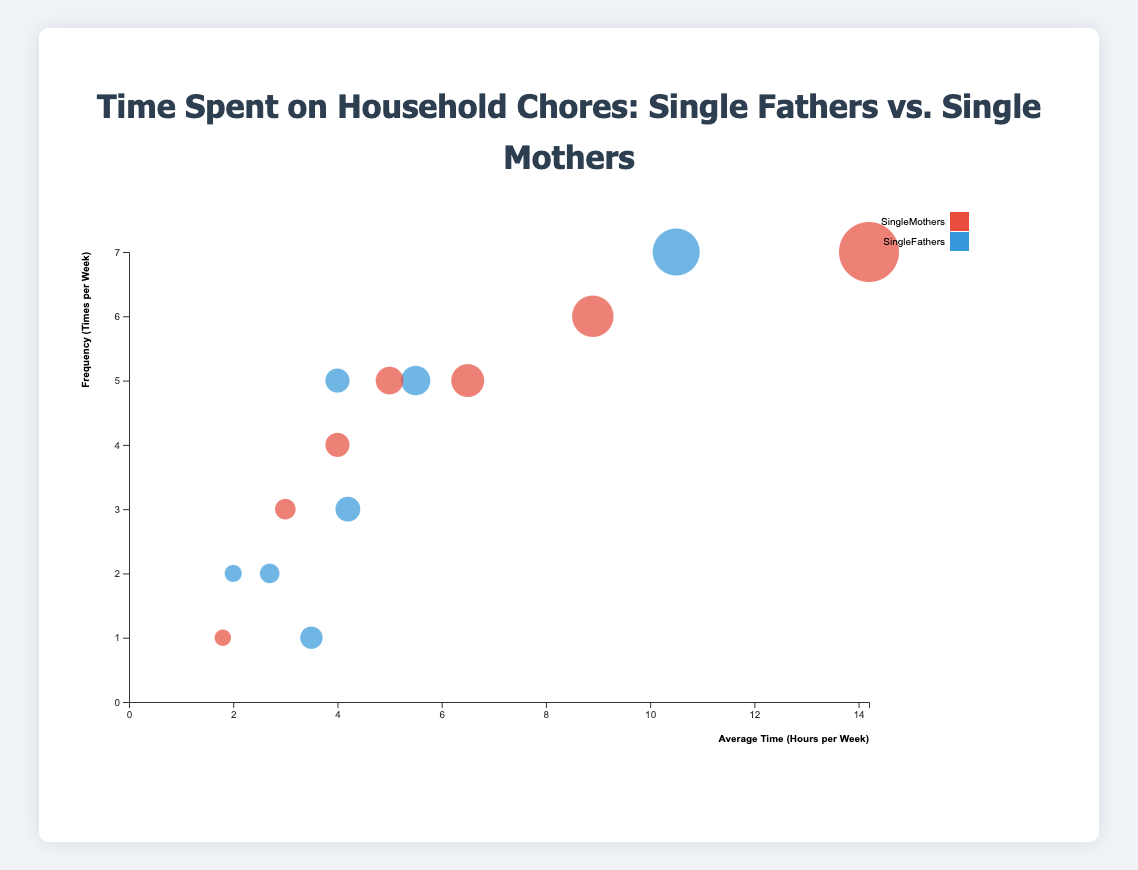What are the two chores where single fathers spend the most and least time? The chart shows bubbles representing the time spent on chores by single fathers. The largest bubble for single fathers is for 'Childcare' (10.5 hours per week) and the smallest is 'Grocery Shopping' (2.0 hours per week).
Answer: Childcare and Grocery Shopping Which chore has the smallest difference in the average time spent between single fathers and single mothers? Compare the differences in average time spent for each chore. For 'Homework Assistance,' it is 5.0 hours (mothers) - 4.0 hours (fathers) = 1.0 hour. This is the smallest difference.
Answer: Homework Assistance On average, how many more times per week do single mothers cook compared to single fathers? Check the frequencies for cooking: 6 times per week for single mothers and 5 times per week for single fathers. The difference is 6 - 5 = 1 time per week.
Answer: 1 Do single fathers or single mothers dedicate more overall time to chores on average according to this chart? Sum up the average weekly hours for each group: Single Fathers: 5.5+4.2+2.7+10.5+3.5+2.0+4.0 = 32.4 hours. Single Mothers: 8.9+6.5+4.0+14.2+1.8+3.0+5.0 = 43.4 hours. Single mothers dedicate more time.
Answer: Single mothers What is the average number of times per week that single parents (both fathers and mothers) do laundry? Add the frequencies for both fathers and mothers: 2 (fathers) + 4 (mothers) = 6. Divide by 2 to get the average: 6 / 2 = 3 times per week.
Answer: 3 Which chore has the largest bubble for single mothers, and how many hours per week is it? Identify the largest bubble for single mothers. 'Childcare' has the largest bubble. Check the corresponding average time: 14.2 hours per week.
Answer: Childcare, 14.2 hours per week Which chore appears to be done most frequently on a weekly basis by both single fathers and single mothers? The y-axis represents the frequency. The highest point for both is 'Childcare', where both have a frequency of 7 times per week.
Answer: Childcare How many chores have a frequency of at least 5 times per week for single mothers? Count the chores with a frequency of 5 or more: Cooking (6), Cleaning (5), Childcare (7), Homework Assistance (5). There are 4 such chores.
Answer: 4 Which household chore shows the biggest disparity in the average time spent per week between single fathers and single mothers? Calculate the differences in time spent for each chore. The largest difference is for 'Childcare' with a difference of 14.2 (mothers) - 10.5 (fathers) = 3.7 hours per week.
Answer: Childcare What general trend can be observed about outdoor maintenance between single fathers and single mothers? Refer to the chart's data for outdoor maintenance. Single fathers spend more time (3.5 hours) compared to single mothers (1.8 hours), indicating fathers spend more time on outdoor maintenance.
Answer: Single fathers spend more time 